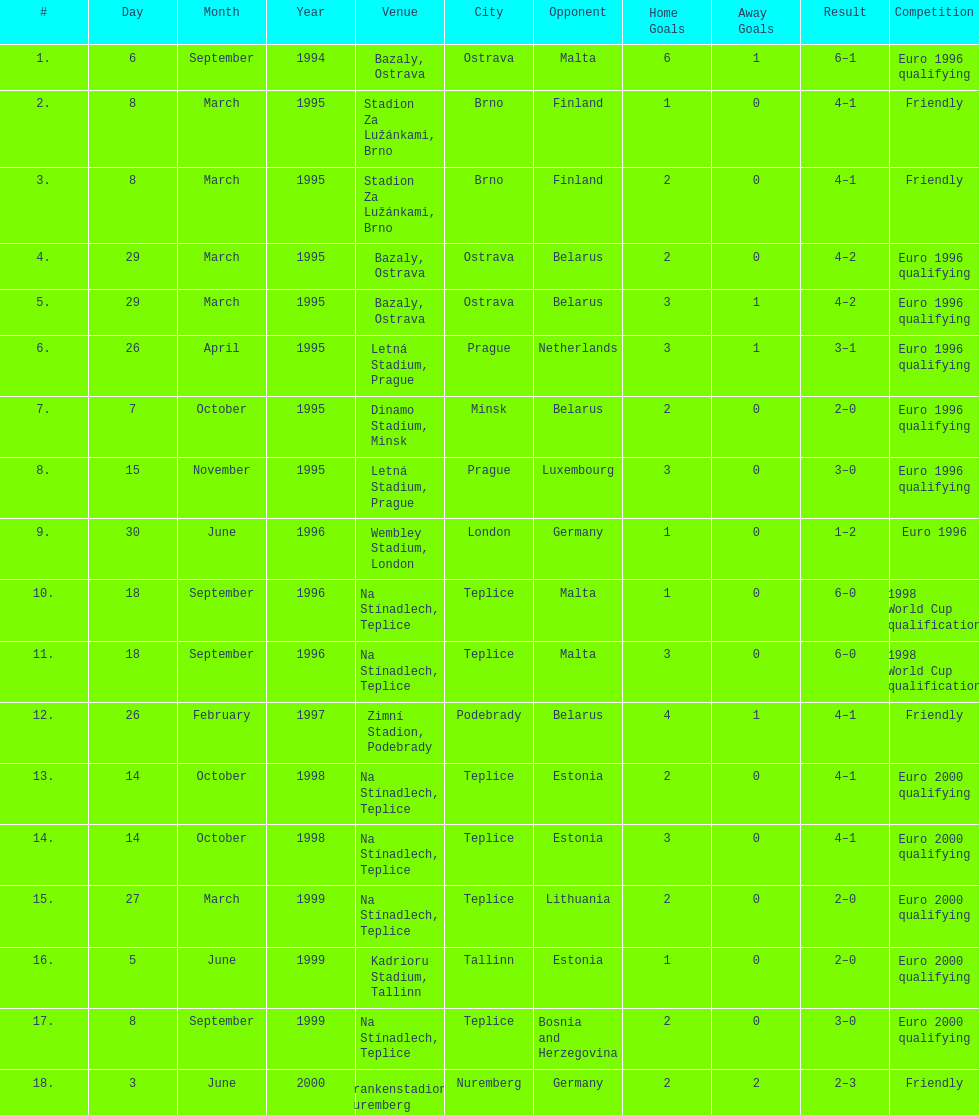What was the number of times czech republic played against germany? 2. 